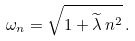Convert formula to latex. <formula><loc_0><loc_0><loc_500><loc_500>\omega _ { n } = \sqrt { 1 + \widetilde { \lambda } \, n ^ { 2 } } \, .</formula> 